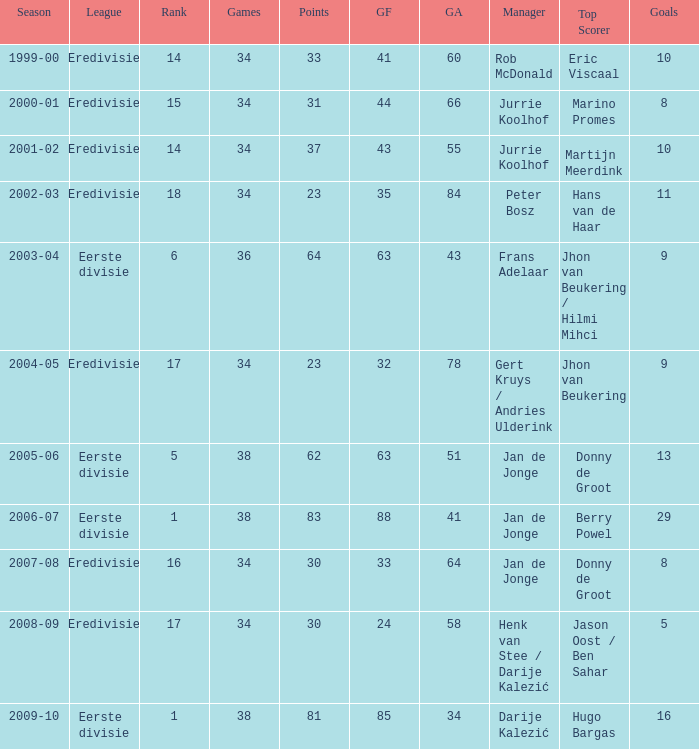Who is the top scorer where gf is 41? Eric Viscaal. 